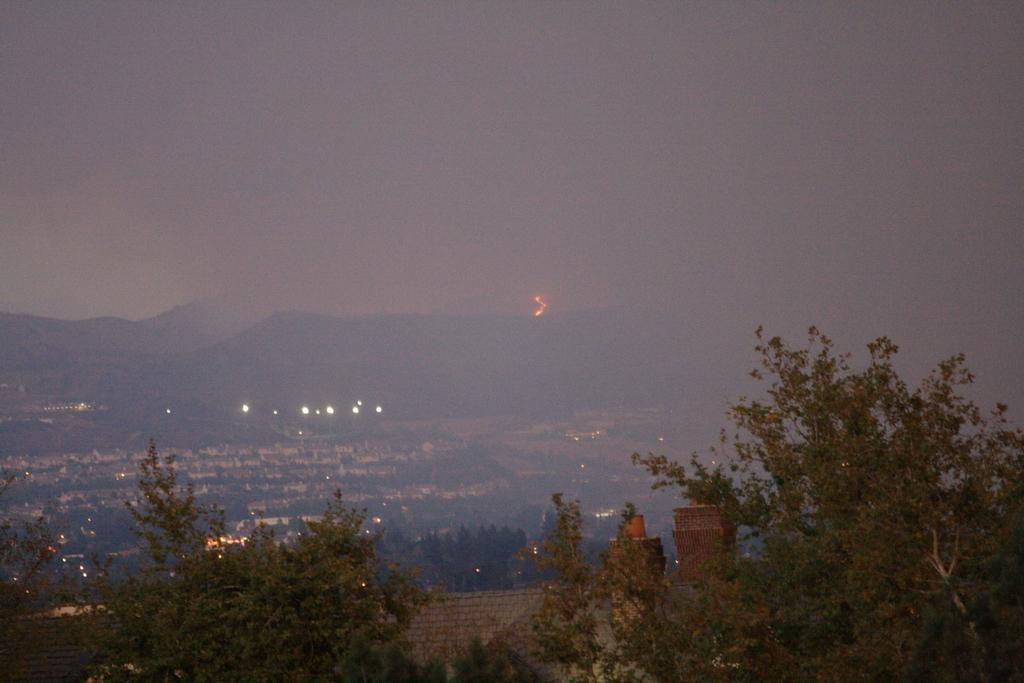What is located in the center of the image? There is a wall in the center of the image. What type of natural elements can be seen in the image? There are trees, plants, and a hill visible in the image. What can be found in the background of the image? The sky, clouds, and a hill can be seen in the background of the image. Are there any artificial light sources in the image? Yes, there are lights in the image. What type of ticket is visible in the image? There is no ticket present in the image. How many stitches are used to create the plants in the image? The plants in the image are not made of fabric or any material that requires stitching; they are real plants. 